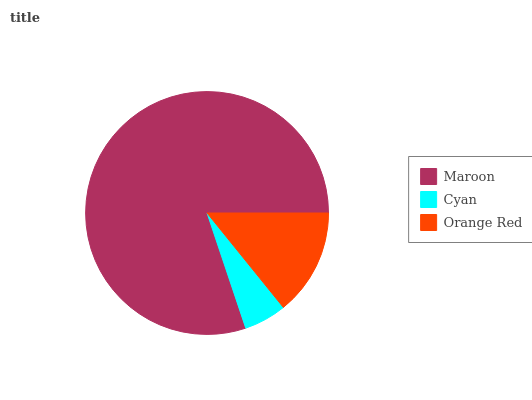Is Cyan the minimum?
Answer yes or no. Yes. Is Maroon the maximum?
Answer yes or no. Yes. Is Orange Red the minimum?
Answer yes or no. No. Is Orange Red the maximum?
Answer yes or no. No. Is Orange Red greater than Cyan?
Answer yes or no. Yes. Is Cyan less than Orange Red?
Answer yes or no. Yes. Is Cyan greater than Orange Red?
Answer yes or no. No. Is Orange Red less than Cyan?
Answer yes or no. No. Is Orange Red the high median?
Answer yes or no. Yes. Is Orange Red the low median?
Answer yes or no. Yes. Is Maroon the high median?
Answer yes or no. No. Is Cyan the low median?
Answer yes or no. No. 